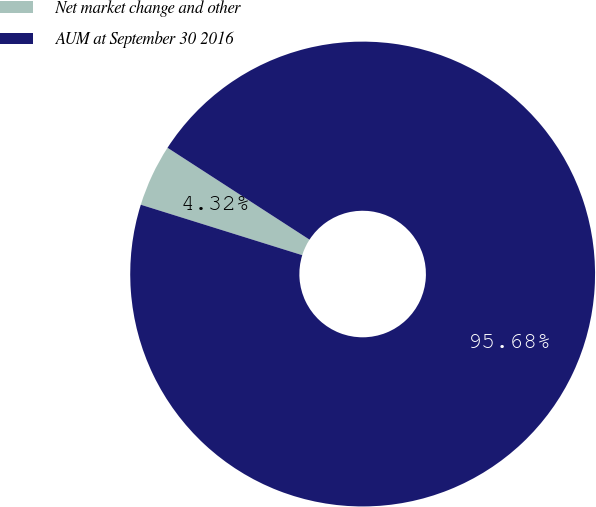<chart> <loc_0><loc_0><loc_500><loc_500><pie_chart><fcel>Net market change and other<fcel>AUM at September 30 2016<nl><fcel>4.32%<fcel>95.68%<nl></chart> 